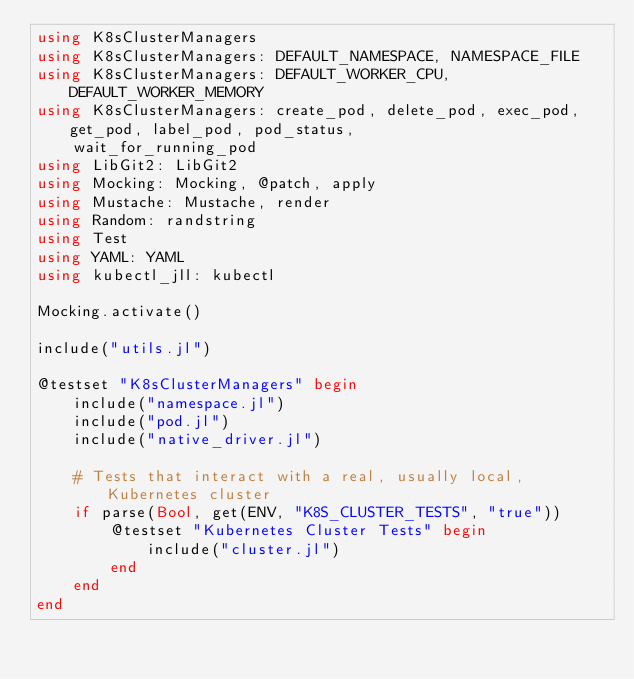<code> <loc_0><loc_0><loc_500><loc_500><_Julia_>using K8sClusterManagers
using K8sClusterManagers: DEFAULT_NAMESPACE, NAMESPACE_FILE
using K8sClusterManagers: DEFAULT_WORKER_CPU, DEFAULT_WORKER_MEMORY
using K8sClusterManagers: create_pod, delete_pod, exec_pod, get_pod, label_pod, pod_status,
    wait_for_running_pod
using LibGit2: LibGit2
using Mocking: Mocking, @patch, apply
using Mustache: Mustache, render
using Random: randstring
using Test
using YAML: YAML
using kubectl_jll: kubectl

Mocking.activate()

include("utils.jl")

@testset "K8sClusterManagers" begin
    include("namespace.jl")
    include("pod.jl")
    include("native_driver.jl")

    # Tests that interact with a real, usually local, Kubernetes cluster
    if parse(Bool, get(ENV, "K8S_CLUSTER_TESTS", "true"))
        @testset "Kubernetes Cluster Tests" begin
            include("cluster.jl")
        end
    end
end
</code> 